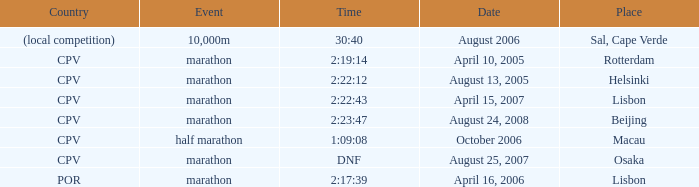What is the Place of the Event on August 25, 2007? Osaka. 